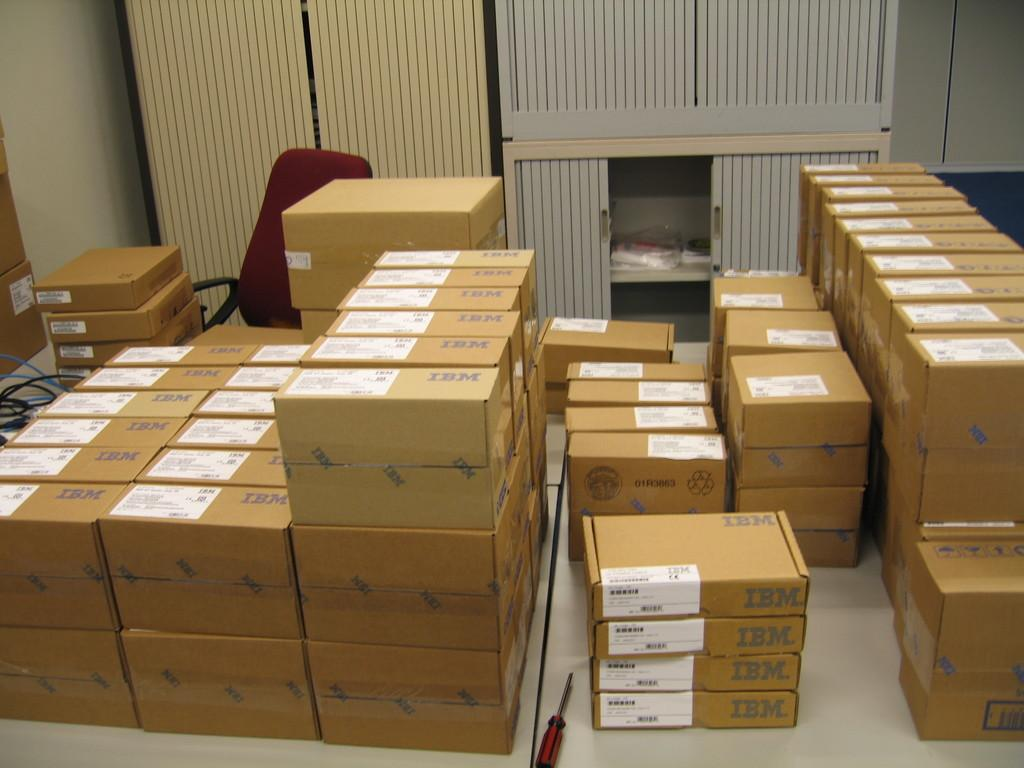<image>
Summarize the visual content of the image. Many sealed card board boxes for IBM on a floor 